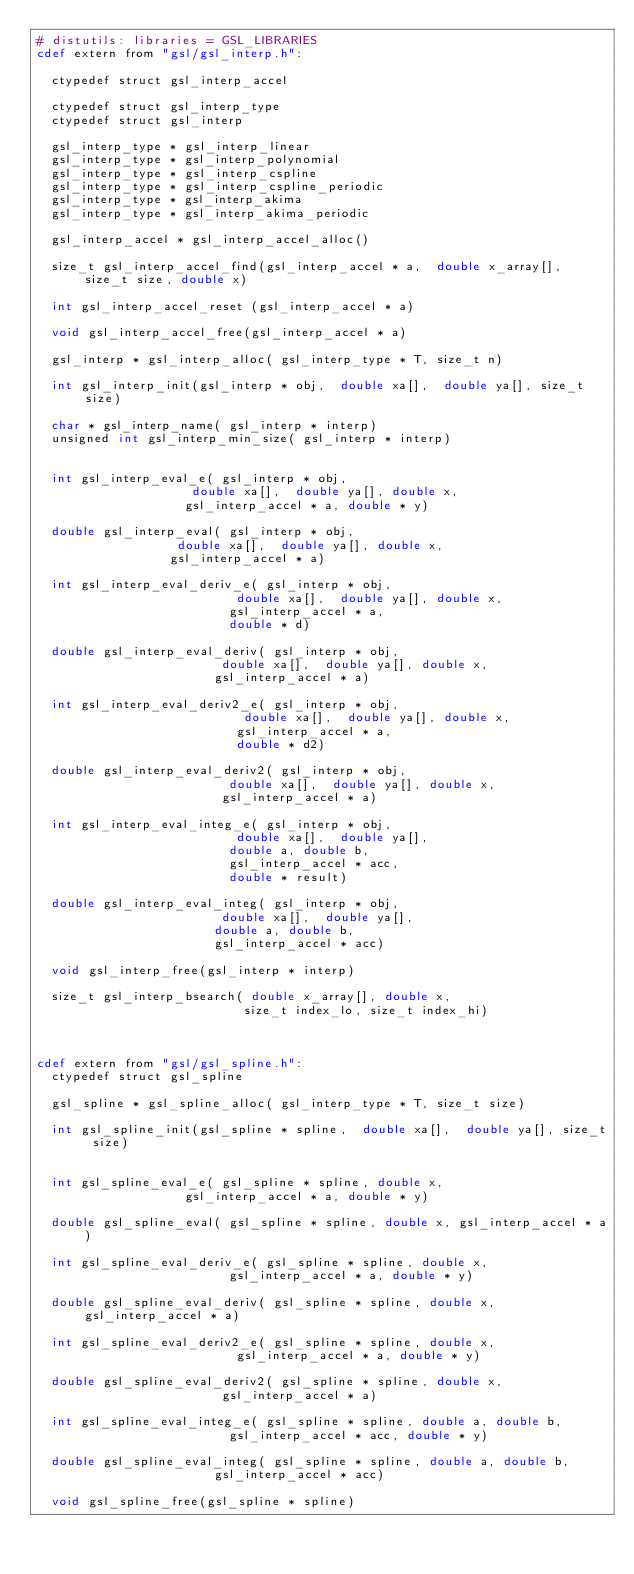Convert code to text. <code><loc_0><loc_0><loc_500><loc_500><_Cython_># distutils: libraries = GSL_LIBRARIES
cdef extern from "gsl/gsl_interp.h":

  ctypedef struct gsl_interp_accel

  ctypedef struct gsl_interp_type
  ctypedef struct gsl_interp

  gsl_interp_type * gsl_interp_linear
  gsl_interp_type * gsl_interp_polynomial
  gsl_interp_type * gsl_interp_cspline
  gsl_interp_type * gsl_interp_cspline_periodic
  gsl_interp_type * gsl_interp_akima
  gsl_interp_type * gsl_interp_akima_periodic

  gsl_interp_accel * gsl_interp_accel_alloc()

  size_t gsl_interp_accel_find(gsl_interp_accel * a,  double x_array[], size_t size, double x)

  int gsl_interp_accel_reset (gsl_interp_accel * a)

  void gsl_interp_accel_free(gsl_interp_accel * a)

  gsl_interp * gsl_interp_alloc( gsl_interp_type * T, size_t n)

  int gsl_interp_init(gsl_interp * obj,  double xa[],  double ya[], size_t size)

  char * gsl_interp_name( gsl_interp * interp)
  unsigned int gsl_interp_min_size( gsl_interp * interp)


  int gsl_interp_eval_e( gsl_interp * obj,
                     double xa[],  double ya[], double x,
                    gsl_interp_accel * a, double * y)

  double gsl_interp_eval( gsl_interp * obj,
                   double xa[],  double ya[], double x,
                  gsl_interp_accel * a)

  int gsl_interp_eval_deriv_e( gsl_interp * obj,
                           double xa[],  double ya[], double x,
                          gsl_interp_accel * a,
                          double * d)

  double gsl_interp_eval_deriv( gsl_interp * obj,
                         double xa[],  double ya[], double x,
                        gsl_interp_accel * a)

  int gsl_interp_eval_deriv2_e( gsl_interp * obj,
                            double xa[],  double ya[], double x,
                           gsl_interp_accel * a,
                           double * d2)

  double gsl_interp_eval_deriv2( gsl_interp * obj,
                          double xa[],  double ya[], double x,
                         gsl_interp_accel * a)

  int gsl_interp_eval_integ_e( gsl_interp * obj,
                           double xa[],  double ya[],
                          double a, double b,
                          gsl_interp_accel * acc,
                          double * result)

  double gsl_interp_eval_integ( gsl_interp * obj,
                         double xa[],  double ya[],
                        double a, double b,
                        gsl_interp_accel * acc)

  void gsl_interp_free(gsl_interp * interp)

  size_t gsl_interp_bsearch( double x_array[], double x,
                            size_t index_lo, size_t index_hi)



cdef extern from "gsl/gsl_spline.h":
  ctypedef struct gsl_spline

  gsl_spline * gsl_spline_alloc( gsl_interp_type * T, size_t size)

  int gsl_spline_init(gsl_spline * spline,  double xa[],  double ya[], size_t size)


  int gsl_spline_eval_e( gsl_spline * spline, double x,
                    gsl_interp_accel * a, double * y)

  double gsl_spline_eval( gsl_spline * spline, double x, gsl_interp_accel * a)

  int gsl_spline_eval_deriv_e( gsl_spline * spline, double x,
                          gsl_interp_accel * a, double * y)

  double gsl_spline_eval_deriv( gsl_spline * spline, double x, gsl_interp_accel * a)

  int gsl_spline_eval_deriv2_e( gsl_spline * spline, double x,
                           gsl_interp_accel * a, double * y)

  double gsl_spline_eval_deriv2( gsl_spline * spline, double x,
                         gsl_interp_accel * a)

  int gsl_spline_eval_integ_e( gsl_spline * spline, double a, double b,
                          gsl_interp_accel * acc, double * y)

  double gsl_spline_eval_integ( gsl_spline * spline, double a, double b,
                        gsl_interp_accel * acc)

  void gsl_spline_free(gsl_spline * spline)

</code> 